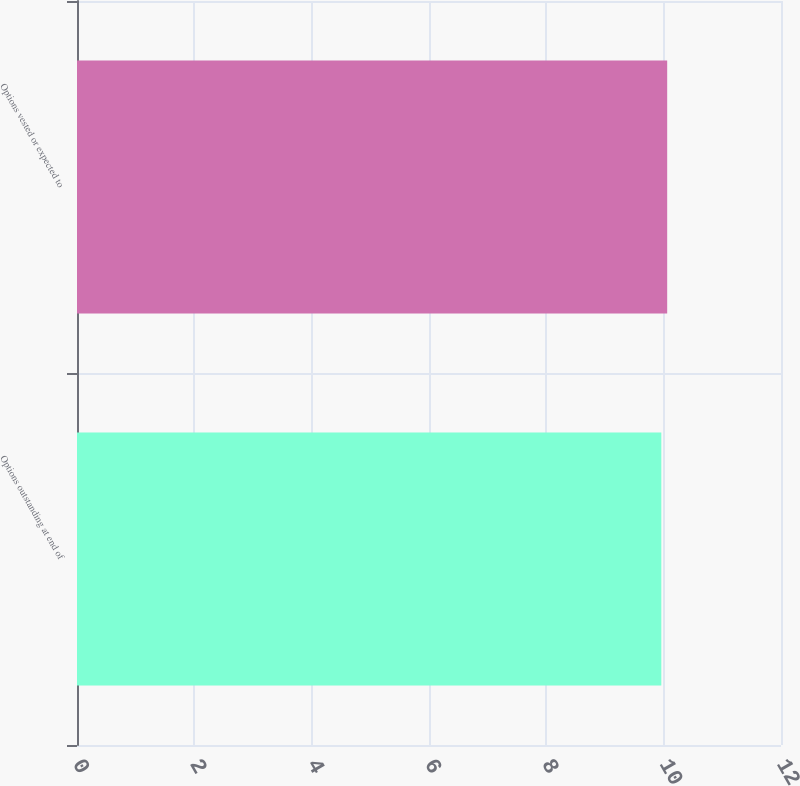<chart> <loc_0><loc_0><loc_500><loc_500><bar_chart><fcel>Options outstanding at end of<fcel>Options vested or expected to<nl><fcel>9.96<fcel>10.06<nl></chart> 